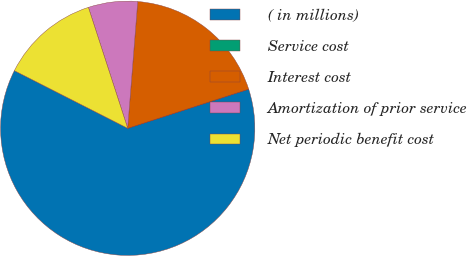Convert chart. <chart><loc_0><loc_0><loc_500><loc_500><pie_chart><fcel>( in millions)<fcel>Service cost<fcel>Interest cost<fcel>Amortization of prior service<fcel>Net periodic benefit cost<nl><fcel>62.45%<fcel>0.02%<fcel>18.75%<fcel>6.26%<fcel>12.51%<nl></chart> 